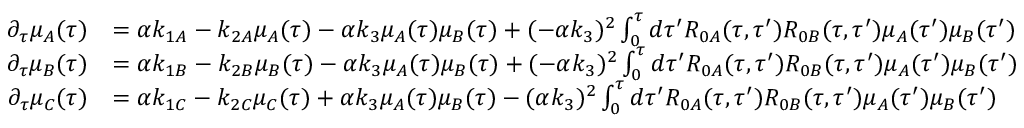<formula> <loc_0><loc_0><loc_500><loc_500>\begin{array} { r l } { \partial _ { \tau } \mu _ { A } ( \tau ) } & { = \alpha k _ { 1 A } - k _ { 2 A } \mu _ { A } ( \tau ) - \alpha k _ { 3 } \mu _ { A } ( \tau ) \mu _ { B } ( \tau ) + ( - \alpha k _ { 3 } ) ^ { 2 } \int _ { 0 } ^ { \tau } d \tau ^ { \prime } R _ { 0 A } ( \tau , \tau ^ { \prime } ) R _ { 0 B } ( \tau , \tau ^ { \prime } ) \mu _ { A } ( \tau ^ { \prime } ) \mu _ { B } ( \tau ^ { \prime } ) } \\ { \partial _ { \tau } \mu _ { B } ( \tau ) } & { = \alpha k _ { 1 B } - k _ { 2 B } \mu _ { B } ( \tau ) - \alpha k _ { 3 } \mu _ { A } ( \tau ) \mu _ { B } ( \tau ) + ( - \alpha k _ { 3 } ) ^ { 2 } \int _ { 0 } ^ { \tau } d \tau ^ { \prime } R _ { 0 A } ( \tau , \tau ^ { \prime } ) R _ { 0 B } ( \tau , \tau ^ { \prime } ) \mu _ { A } ( \tau ^ { \prime } ) \mu _ { B } ( \tau ^ { \prime } ) } \\ { \partial _ { \tau } \mu _ { C } ( \tau ) } & { = \alpha k _ { 1 C } - k _ { 2 C } \mu _ { C } ( \tau ) + \alpha k _ { 3 } \mu _ { A } ( \tau ) \mu _ { B } ( \tau ) - ( \alpha k _ { 3 } ) ^ { 2 } \int _ { 0 } ^ { \tau } d \tau ^ { \prime } R _ { 0 A } ( \tau , \tau ^ { \prime } ) R _ { 0 B } ( \tau , \tau ^ { \prime } ) \mu _ { A } ( \tau ^ { \prime } ) \mu _ { B } ( \tau ^ { \prime } ) } \end{array}</formula> 